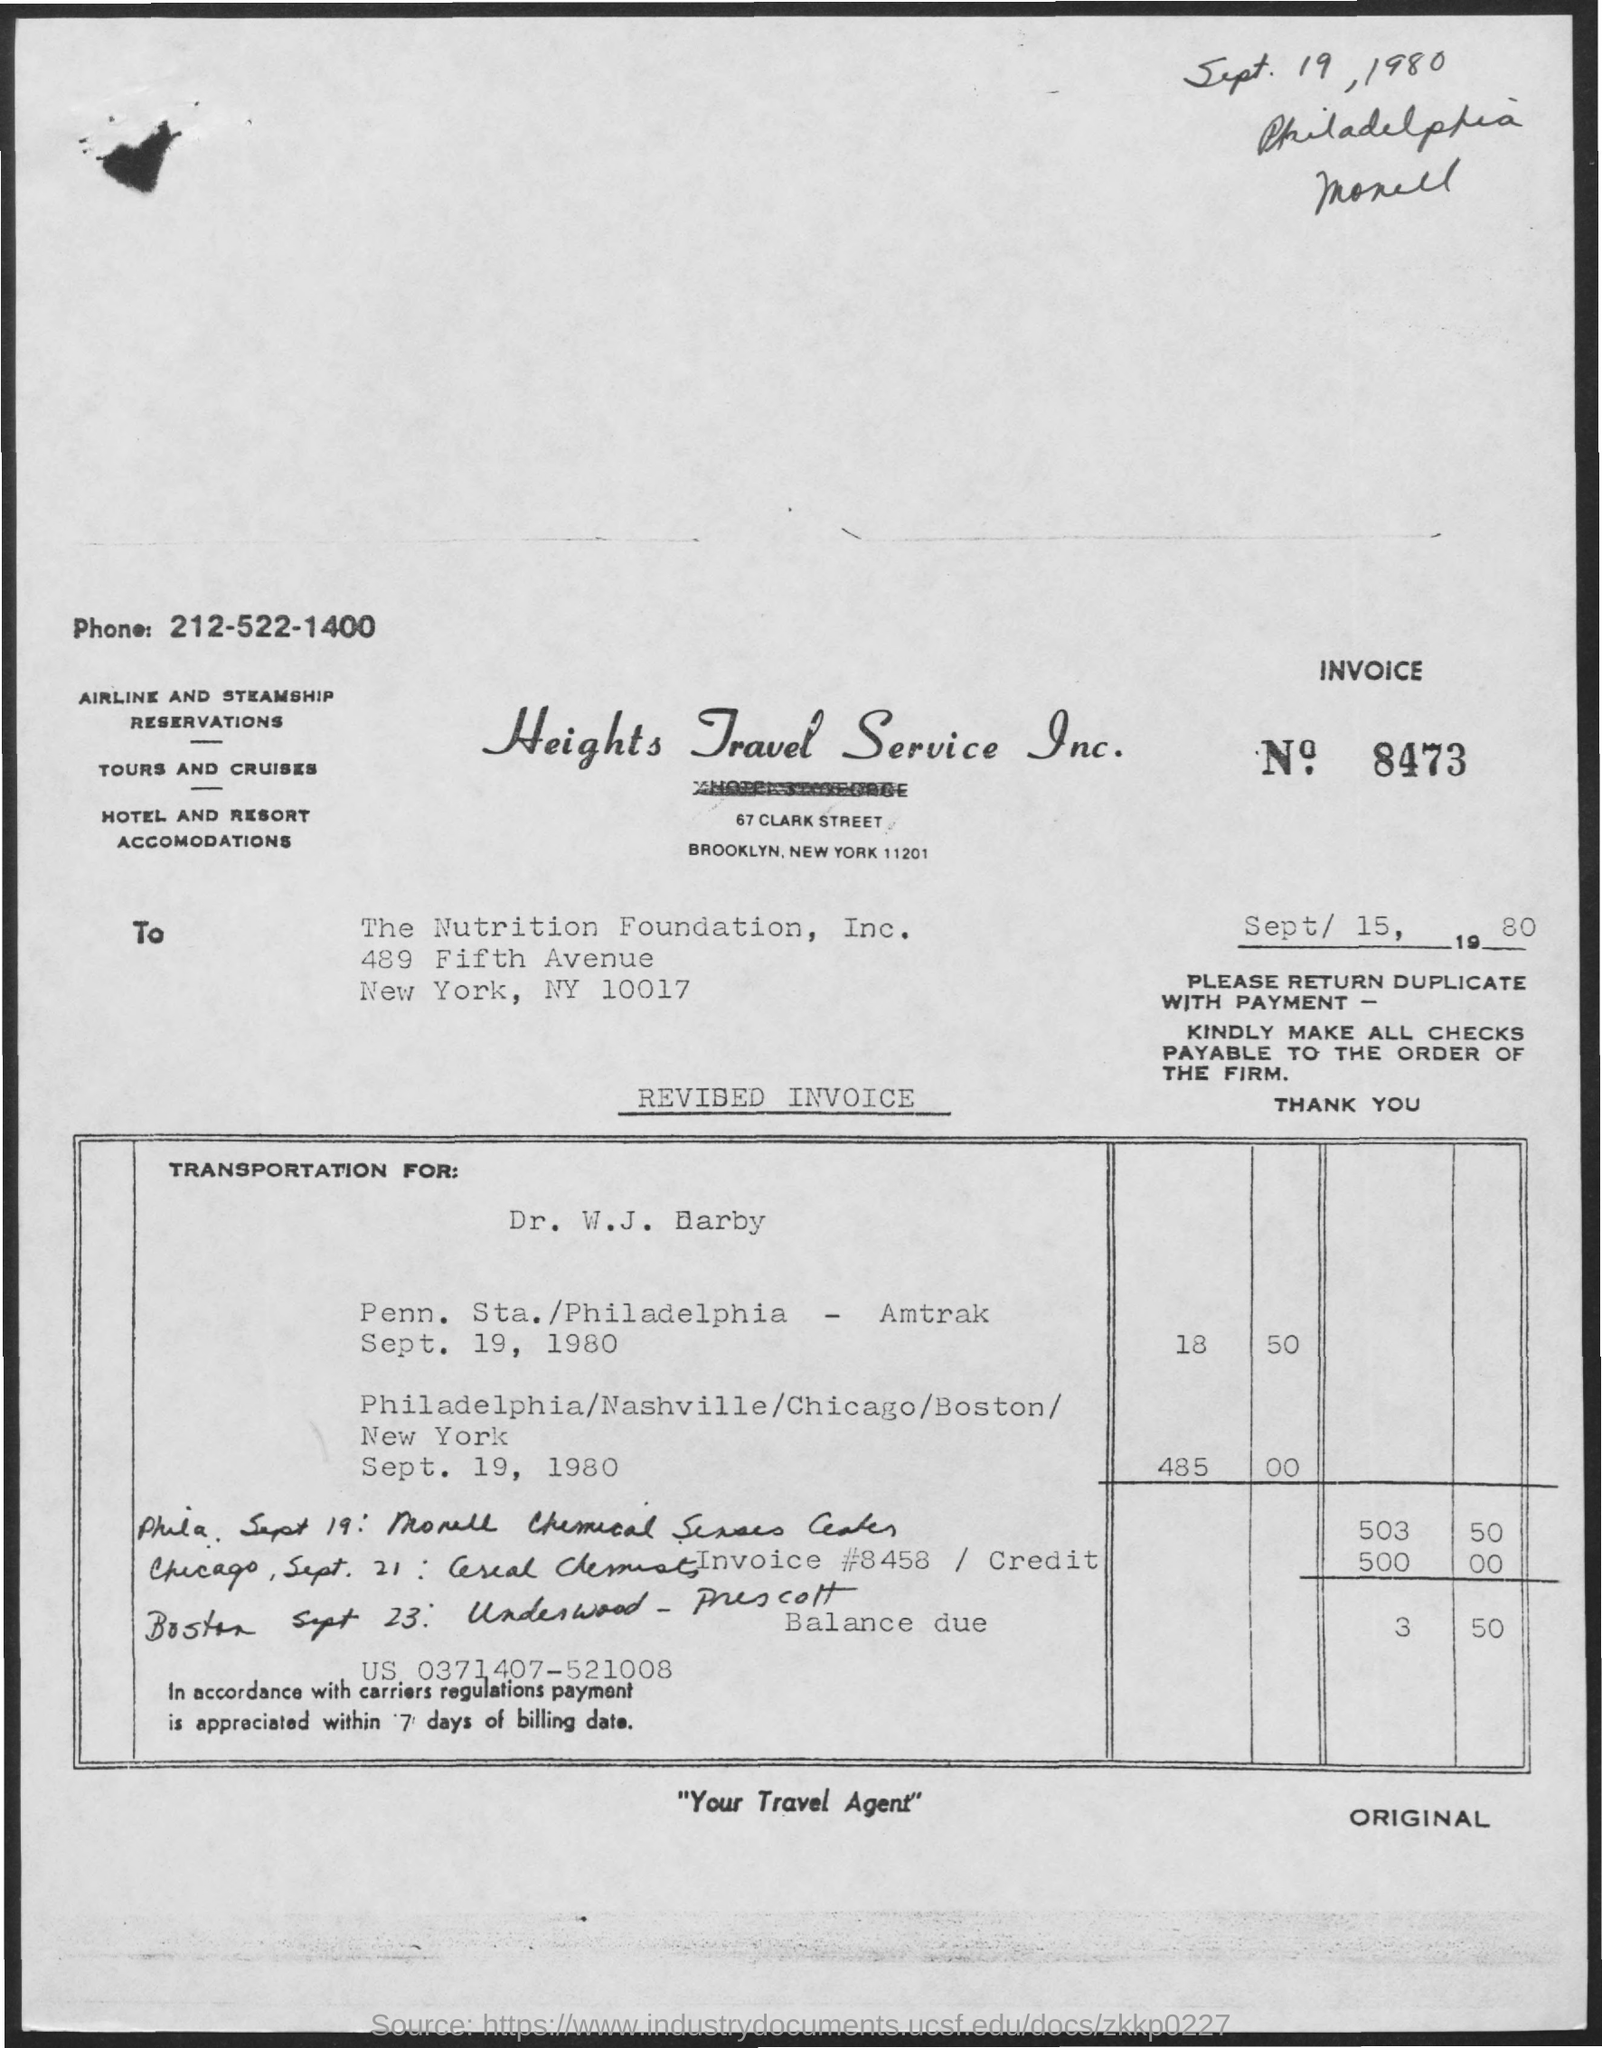Identify some key points in this picture. This letter was written to the Nutrition Foundation, Inc. The phone number mentioned in the given letter is 212-522-1400. The invoice number mentioned in the given form is 8473... 